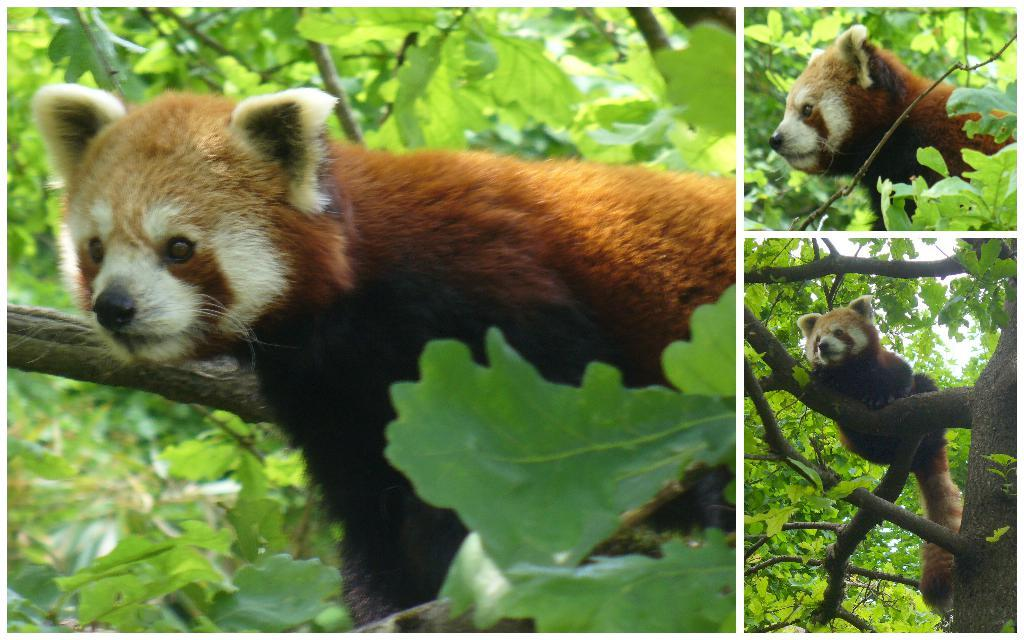How many pictures are included in the collage? The image is a collage of three pictures. What can be seen in one of the pictures? There is an animal on a tree branch in one of the pictures. What is visible in the background of one of the pictures? Leaves are visible in the background of one of the pictures. What type of payment is being made by the servant in the image? There is no servant or payment present in the image; it is a collage of three pictures, one of which features an animal on a tree branch. 